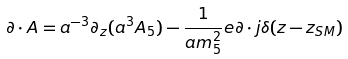Convert formula to latex. <formula><loc_0><loc_0><loc_500><loc_500>\partial \cdot A = a ^ { - 3 } \partial _ { z } ( a ^ { 3 } A _ { 5 } ) - \frac { 1 } { a m ^ { 2 } _ { 5 } } e \partial \cdot j \delta ( z - z _ { S M } )</formula> 